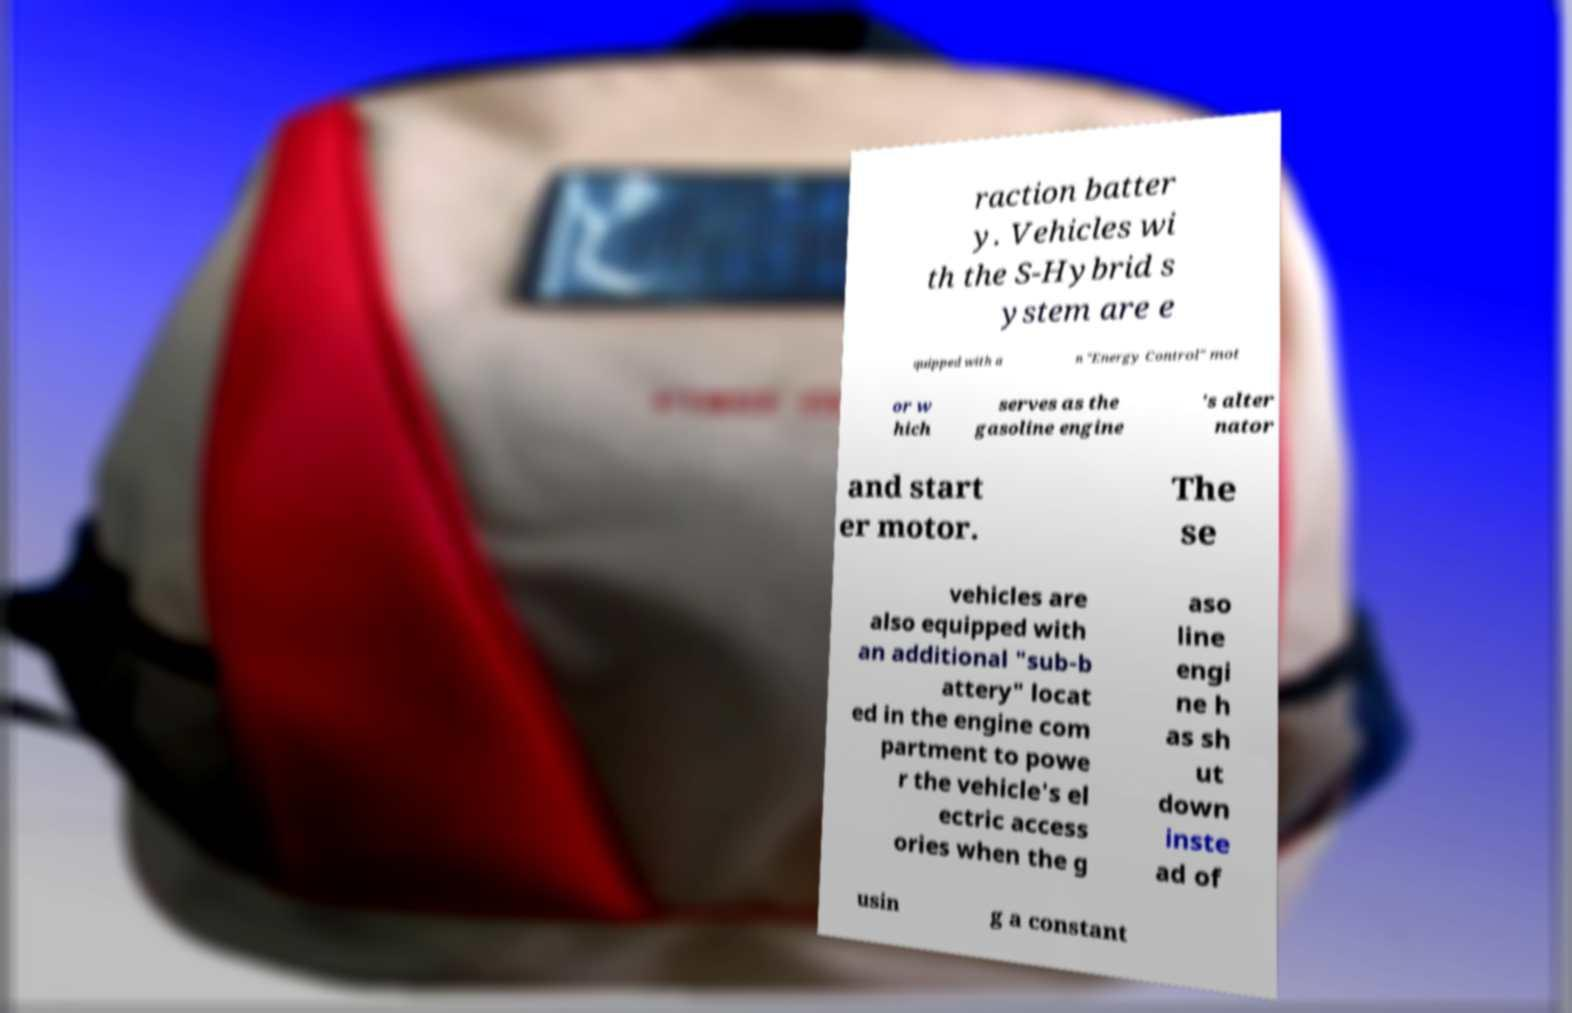There's text embedded in this image that I need extracted. Can you transcribe it verbatim? raction batter y. Vehicles wi th the S-Hybrid s ystem are e quipped with a n "Energy Control" mot or w hich serves as the gasoline engine 's alter nator and start er motor. The se vehicles are also equipped with an additional "sub-b attery" locat ed in the engine com partment to powe r the vehicle's el ectric access ories when the g aso line engi ne h as sh ut down inste ad of usin g a constant 